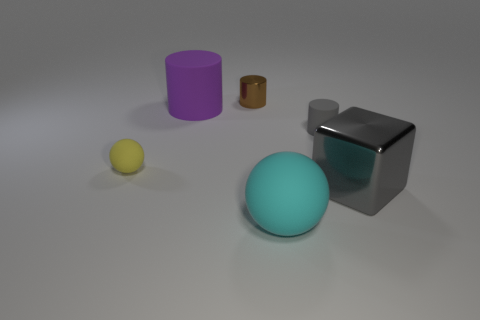Do the matte cylinder that is right of the large cyan matte thing and the rubber sphere in front of the gray shiny object have the same color?
Your response must be concise. No. The brown metallic object that is the same shape as the big purple matte object is what size?
Provide a short and direct response. Small. Is the material of the big thing behind the gray matte cylinder the same as the small thing that is on the left side of the purple cylinder?
Ensure brevity in your answer.  Yes. What number of shiny objects are tiny yellow objects or purple cylinders?
Provide a short and direct response. 0. There is a thing behind the purple matte object behind the tiny matte thing right of the brown thing; what is its material?
Provide a succinct answer. Metal. There is a small matte thing to the right of the yellow object; does it have the same shape as the big thing that is to the left of the cyan rubber object?
Give a very brief answer. Yes. What color is the small thing behind the gray thing that is to the left of the big gray metallic thing?
Keep it short and to the point. Brown. What number of cylinders are either red things or large purple matte things?
Offer a very short reply. 1. How many gray rubber things are behind the tiny rubber object in front of the matte cylinder right of the big cyan object?
Your response must be concise. 1. The metal object that is the same color as the small matte cylinder is what size?
Offer a terse response. Large. 